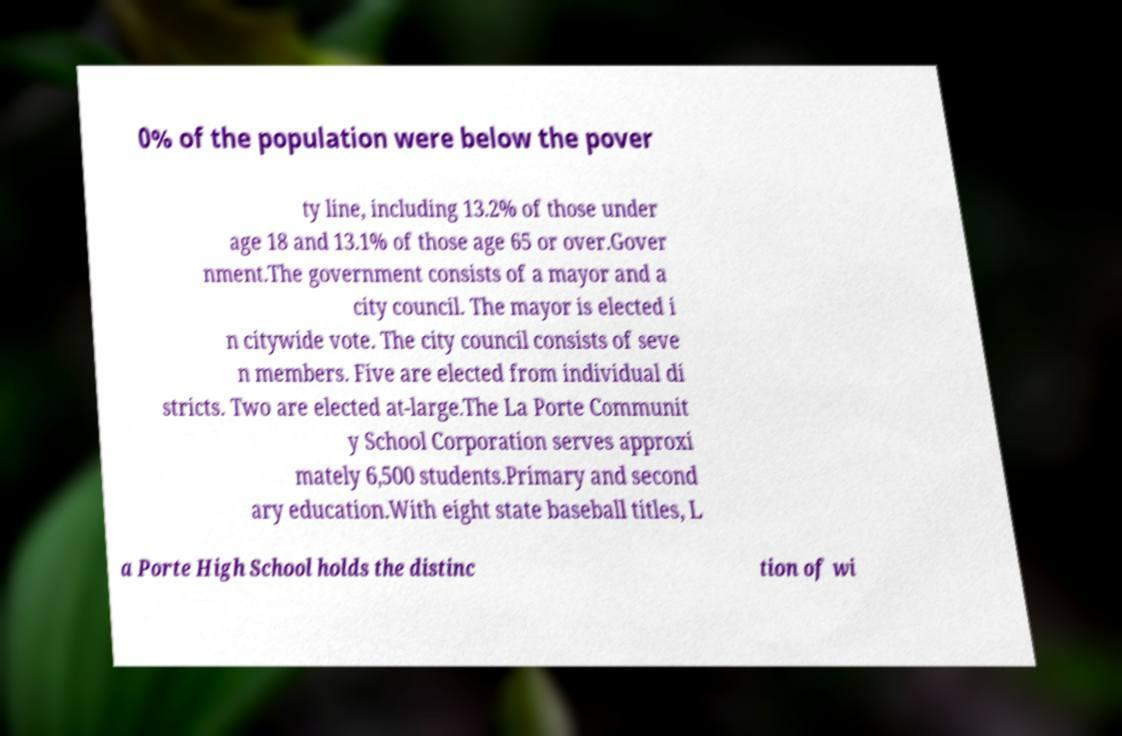Can you read and provide the text displayed in the image?This photo seems to have some interesting text. Can you extract and type it out for me? 0% of the population were below the pover ty line, including 13.2% of those under age 18 and 13.1% of those age 65 or over.Gover nment.The government consists of a mayor and a city council. The mayor is elected i n citywide vote. The city council consists of seve n members. Five are elected from individual di stricts. Two are elected at-large.The La Porte Communit y School Corporation serves approxi mately 6,500 students.Primary and second ary education.With eight state baseball titles, L a Porte High School holds the distinc tion of wi 